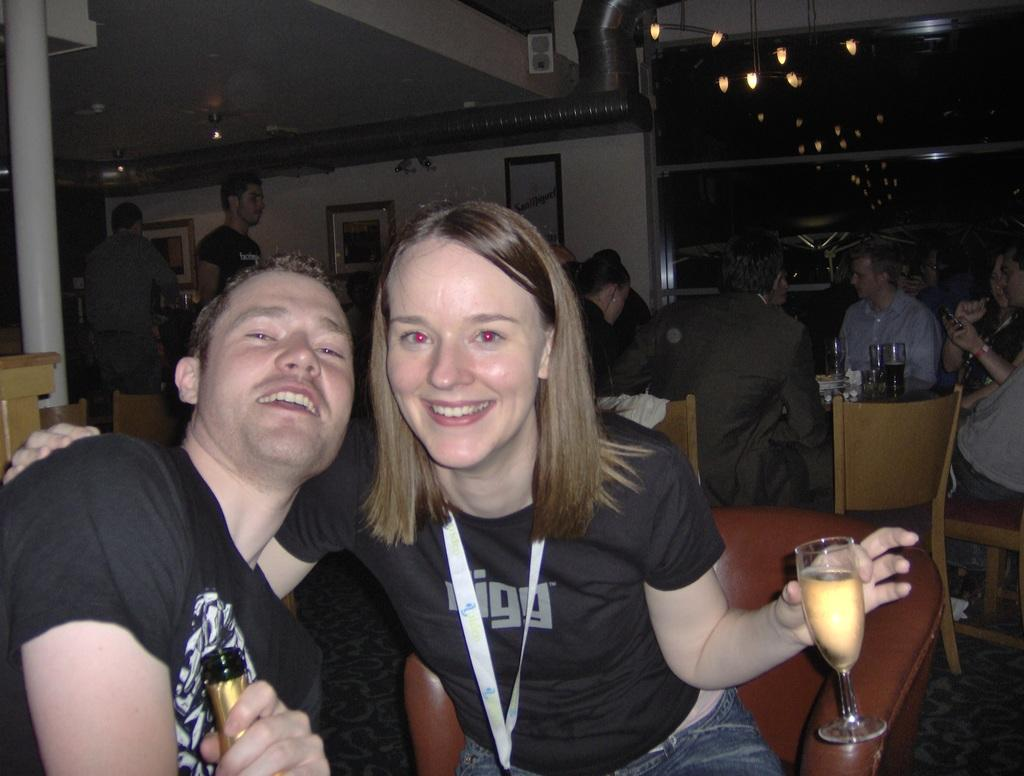<image>
Write a terse but informative summary of the picture. A woman wearing a Vigg branded t-shirt is enjoying a glass of champagne with a guy. 